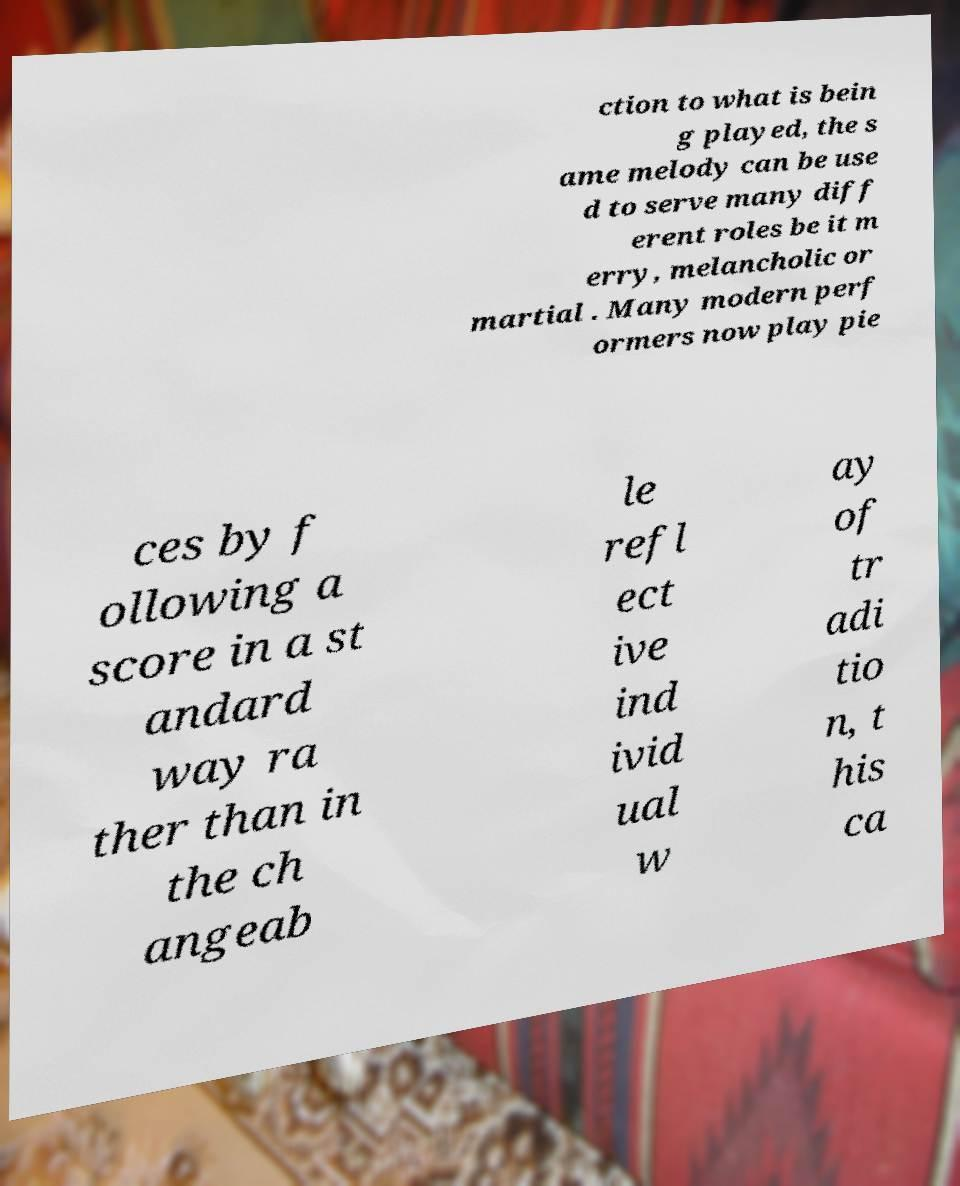Please identify and transcribe the text found in this image. ction to what is bein g played, the s ame melody can be use d to serve many diff erent roles be it m erry, melancholic or martial . Many modern perf ormers now play pie ces by f ollowing a score in a st andard way ra ther than in the ch angeab le refl ect ive ind ivid ual w ay of tr adi tio n, t his ca 